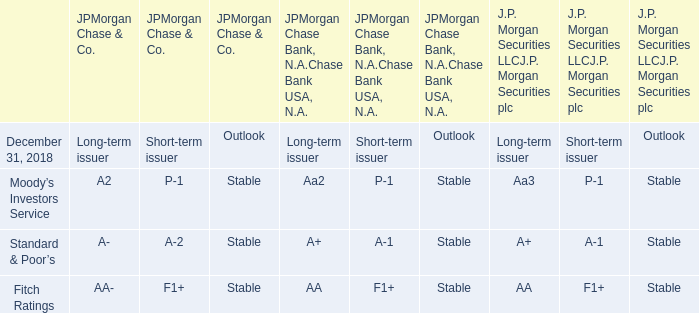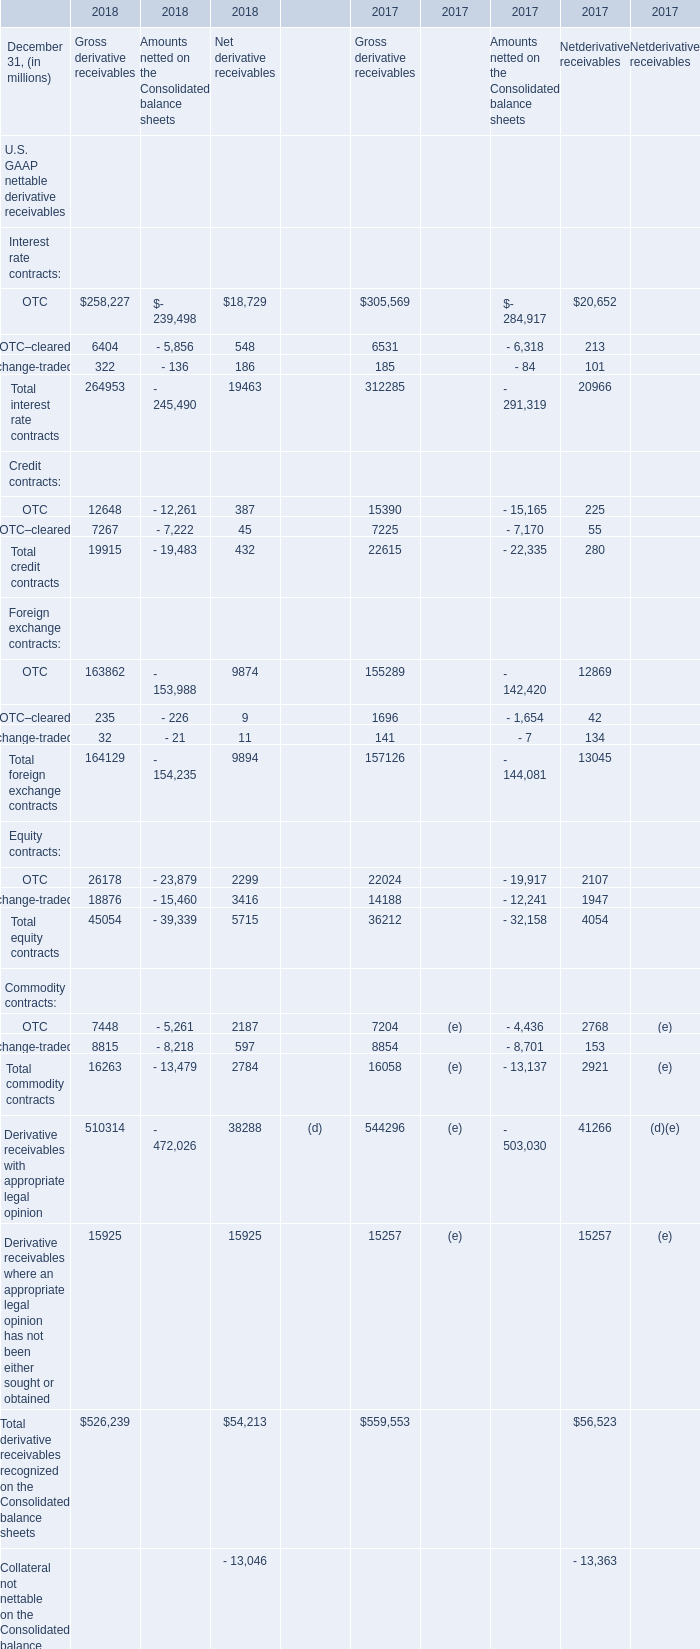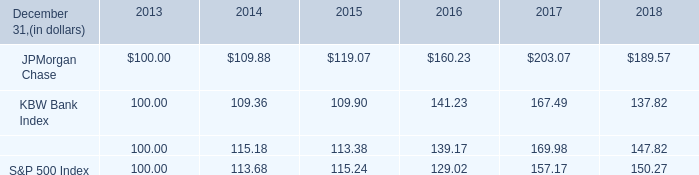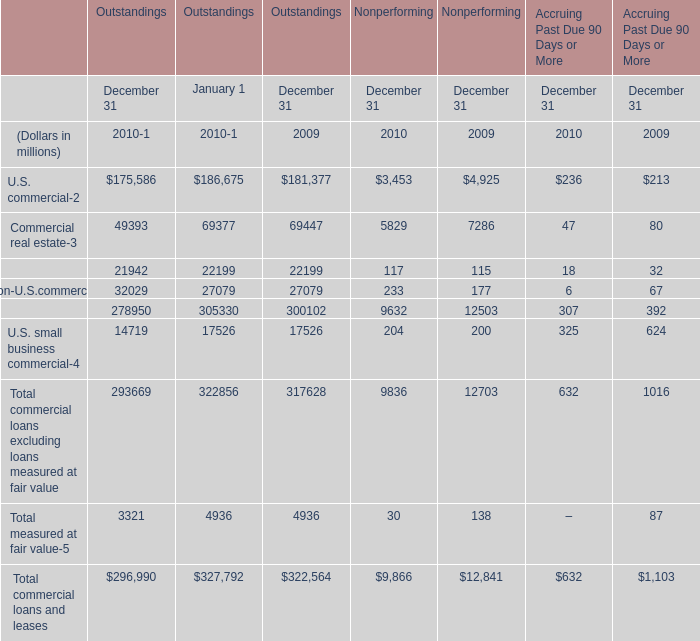what is the estimated variation between the percentual decrease observed in the s&p 500 index and in the jpmorgan chase during the years 2017 and 2018? 
Computations: ((1 - (189.57 / 203.07)) - (1 - (150.27 / 157.17)))
Answer: 0.02258. 